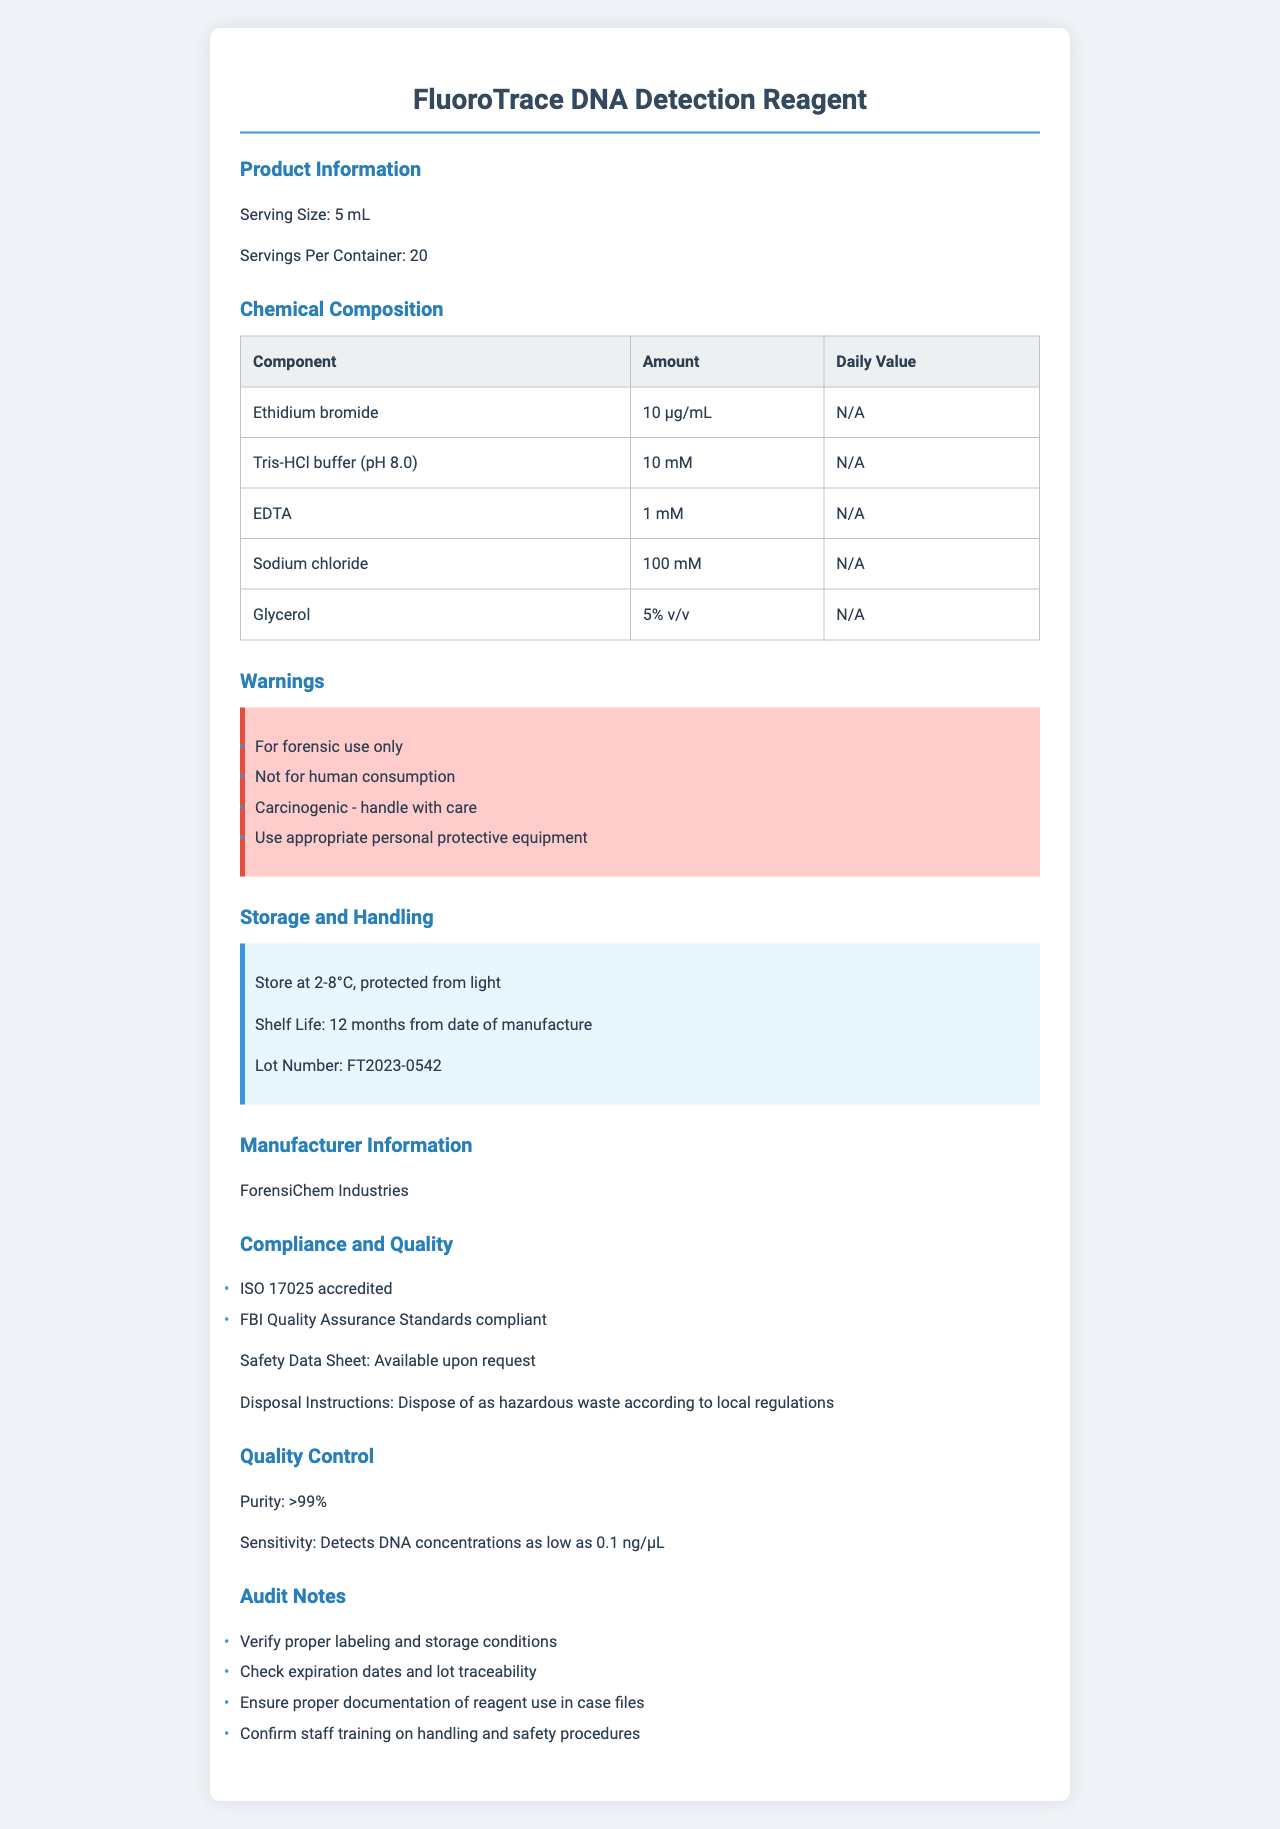What is the serving size of the FluoroTrace DNA Detection Reagent? The label in the "Product Information" section clearly states the serving size as 5 mL.
Answer: 5 mL How many servings are available per container? The "Product Information" section mentions that there are 20 servings per container.
Answer: 20 List two chemicals that are part of the FluoroTrace DNA Detection Reagent's composition. The "Chemical Composition" section lists the components, including Ethidium bromide and Tris-HCl buffer (pH 8.0).
Answer: Ethidium bromide, Tris-HCl buffer (pH 8.0) What are the storage instructions for the FluoroTrace DNA Detection Reagent? The "Storage and Handling" section provides storage instructions that indicate storing the reagent at 2-8°C and protecting it from light.
Answer: Store at 2-8°C, protected from light Which organization has accredited the manufacturer of the FluoroTrace DNA Detection Reagent? The "Compliance and Quality" section lists "ISO 17025 accredited" under compliance certifications.
Answer: ISO 17025 Which chemical in the FluoroTrace DNA Detection Reagent is carcinogenic? A. Ethidium bromide B. Sodium chloride C. Glycerol D. EDTA The "Warnings" section indicates that Ethidium bromide is carcinogenic.
Answer: A. Ethidium bromide What is the primary purpose of the FluoroTrace DNA Detection Reagent? A. Medical treatment B. DNA detection for forensic use C. Food analysis The "Warnings" section mentions "For forensic use only," indicating its primary purpose is for forensic DNA detection.
Answer: B. DNA detection for forensic use Is Ethidium bromide safe to consume? Yes/No The "Warnings" section states "Not for human consumption" and mentions that Ethidium bromide is carcinogenic and should be handled with care.
Answer: No What should you do if you need safety information about this reagent? The "Compliance and Quality" section states that the safety data sheet is available upon request.
Answer: Request the safety data sheet Can you determine the exact manufacturing date of the reagent from the document? The document mentions the shelf life of 12 months from the date of manufacture but does not specify the exact manufacturing date.
Answer: No Summarize the main idea of the document. The document provides detailed information on the forensic reagent, including its composition, usage, safety precautions, and quality standards to ensure proper handling and compliance.
Answer: The document is a comprehensive Nutritional Facts Label for the FluoroTrace DNA Detection Reagent, outlining its chemical composition, storage instructions, safety warnings, manufacturer information, compliance certifications, quality control details, and audit notes. 